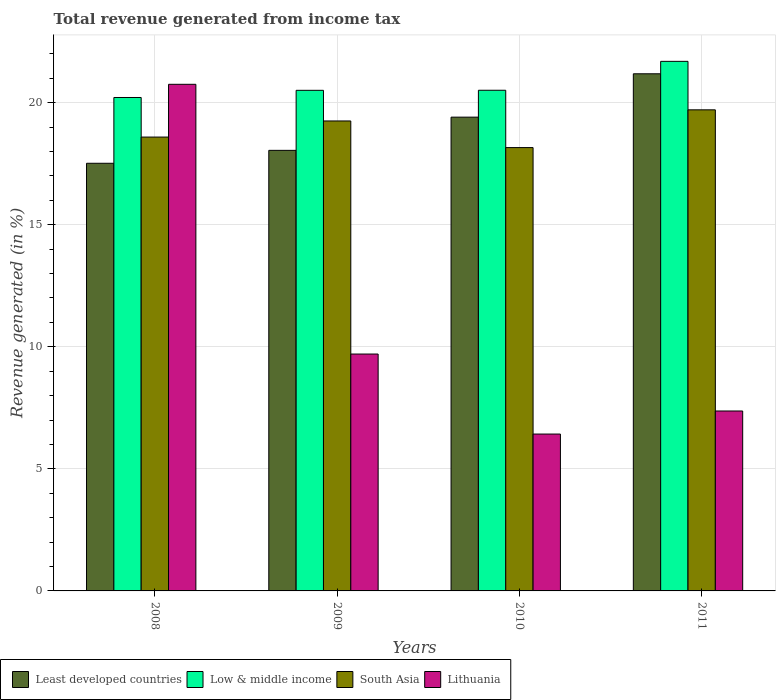How many different coloured bars are there?
Give a very brief answer. 4. How many groups of bars are there?
Make the answer very short. 4. What is the label of the 1st group of bars from the left?
Offer a very short reply. 2008. In how many cases, is the number of bars for a given year not equal to the number of legend labels?
Make the answer very short. 0. What is the total revenue generated in South Asia in 2010?
Your answer should be compact. 18.16. Across all years, what is the maximum total revenue generated in South Asia?
Give a very brief answer. 19.7. Across all years, what is the minimum total revenue generated in Lithuania?
Make the answer very short. 6.42. What is the total total revenue generated in South Asia in the graph?
Provide a succinct answer. 75.7. What is the difference between the total revenue generated in Least developed countries in 2008 and that in 2010?
Give a very brief answer. -1.89. What is the difference between the total revenue generated in Least developed countries in 2011 and the total revenue generated in Low & middle income in 2010?
Ensure brevity in your answer.  0.67. What is the average total revenue generated in South Asia per year?
Offer a very short reply. 18.92. In the year 2011, what is the difference between the total revenue generated in Least developed countries and total revenue generated in South Asia?
Make the answer very short. 1.48. In how many years, is the total revenue generated in Low & middle income greater than 20 %?
Your answer should be compact. 4. What is the ratio of the total revenue generated in Least developed countries in 2009 to that in 2011?
Keep it short and to the point. 0.85. Is the total revenue generated in Low & middle income in 2008 less than that in 2009?
Give a very brief answer. Yes. Is the difference between the total revenue generated in Least developed countries in 2008 and 2010 greater than the difference between the total revenue generated in South Asia in 2008 and 2010?
Give a very brief answer. No. What is the difference between the highest and the second highest total revenue generated in South Asia?
Your response must be concise. 0.46. What is the difference between the highest and the lowest total revenue generated in Least developed countries?
Your response must be concise. 3.67. Is the sum of the total revenue generated in Lithuania in 2008 and 2010 greater than the maximum total revenue generated in South Asia across all years?
Your answer should be very brief. Yes. Is it the case that in every year, the sum of the total revenue generated in Low & middle income and total revenue generated in South Asia is greater than the sum of total revenue generated in Lithuania and total revenue generated in Least developed countries?
Offer a terse response. Yes. What does the 1st bar from the left in 2010 represents?
Your answer should be compact. Least developed countries. What does the 1st bar from the right in 2009 represents?
Make the answer very short. Lithuania. Is it the case that in every year, the sum of the total revenue generated in South Asia and total revenue generated in Least developed countries is greater than the total revenue generated in Lithuania?
Provide a short and direct response. Yes. How many legend labels are there?
Your answer should be compact. 4. What is the title of the graph?
Your answer should be very brief. Total revenue generated from income tax. Does "Comoros" appear as one of the legend labels in the graph?
Your answer should be compact. No. What is the label or title of the Y-axis?
Offer a very short reply. Revenue generated (in %). What is the Revenue generated (in %) of Least developed countries in 2008?
Offer a very short reply. 17.52. What is the Revenue generated (in %) in Low & middle income in 2008?
Provide a short and direct response. 20.21. What is the Revenue generated (in %) in South Asia in 2008?
Your answer should be very brief. 18.59. What is the Revenue generated (in %) in Lithuania in 2008?
Ensure brevity in your answer.  20.75. What is the Revenue generated (in %) in Least developed countries in 2009?
Offer a very short reply. 18.04. What is the Revenue generated (in %) of Low & middle income in 2009?
Your response must be concise. 20.5. What is the Revenue generated (in %) in South Asia in 2009?
Provide a succinct answer. 19.25. What is the Revenue generated (in %) in Lithuania in 2009?
Offer a very short reply. 9.7. What is the Revenue generated (in %) in Least developed countries in 2010?
Keep it short and to the point. 19.4. What is the Revenue generated (in %) of Low & middle income in 2010?
Give a very brief answer. 20.51. What is the Revenue generated (in %) in South Asia in 2010?
Your answer should be very brief. 18.16. What is the Revenue generated (in %) of Lithuania in 2010?
Make the answer very short. 6.42. What is the Revenue generated (in %) in Least developed countries in 2011?
Offer a very short reply. 21.18. What is the Revenue generated (in %) in Low & middle income in 2011?
Provide a succinct answer. 21.69. What is the Revenue generated (in %) of South Asia in 2011?
Provide a short and direct response. 19.7. What is the Revenue generated (in %) in Lithuania in 2011?
Provide a succinct answer. 7.37. Across all years, what is the maximum Revenue generated (in %) in Least developed countries?
Your answer should be very brief. 21.18. Across all years, what is the maximum Revenue generated (in %) in Low & middle income?
Your answer should be compact. 21.69. Across all years, what is the maximum Revenue generated (in %) in South Asia?
Give a very brief answer. 19.7. Across all years, what is the maximum Revenue generated (in %) of Lithuania?
Provide a short and direct response. 20.75. Across all years, what is the minimum Revenue generated (in %) in Least developed countries?
Make the answer very short. 17.52. Across all years, what is the minimum Revenue generated (in %) of Low & middle income?
Give a very brief answer. 20.21. Across all years, what is the minimum Revenue generated (in %) in South Asia?
Provide a short and direct response. 18.16. Across all years, what is the minimum Revenue generated (in %) of Lithuania?
Provide a short and direct response. 6.42. What is the total Revenue generated (in %) of Least developed countries in the graph?
Provide a short and direct response. 76.15. What is the total Revenue generated (in %) of Low & middle income in the graph?
Ensure brevity in your answer.  82.91. What is the total Revenue generated (in %) of South Asia in the graph?
Your answer should be compact. 75.7. What is the total Revenue generated (in %) of Lithuania in the graph?
Provide a short and direct response. 44.25. What is the difference between the Revenue generated (in %) in Least developed countries in 2008 and that in 2009?
Give a very brief answer. -0.53. What is the difference between the Revenue generated (in %) of Low & middle income in 2008 and that in 2009?
Provide a short and direct response. -0.29. What is the difference between the Revenue generated (in %) of South Asia in 2008 and that in 2009?
Ensure brevity in your answer.  -0.66. What is the difference between the Revenue generated (in %) in Lithuania in 2008 and that in 2009?
Offer a very short reply. 11.05. What is the difference between the Revenue generated (in %) in Least developed countries in 2008 and that in 2010?
Make the answer very short. -1.89. What is the difference between the Revenue generated (in %) in Low & middle income in 2008 and that in 2010?
Your response must be concise. -0.3. What is the difference between the Revenue generated (in %) in South Asia in 2008 and that in 2010?
Your response must be concise. 0.43. What is the difference between the Revenue generated (in %) of Lithuania in 2008 and that in 2010?
Your answer should be very brief. 14.32. What is the difference between the Revenue generated (in %) in Least developed countries in 2008 and that in 2011?
Your response must be concise. -3.67. What is the difference between the Revenue generated (in %) of Low & middle income in 2008 and that in 2011?
Your answer should be compact. -1.48. What is the difference between the Revenue generated (in %) of South Asia in 2008 and that in 2011?
Your answer should be very brief. -1.12. What is the difference between the Revenue generated (in %) in Lithuania in 2008 and that in 2011?
Give a very brief answer. 13.38. What is the difference between the Revenue generated (in %) in Least developed countries in 2009 and that in 2010?
Ensure brevity in your answer.  -1.36. What is the difference between the Revenue generated (in %) of Low & middle income in 2009 and that in 2010?
Give a very brief answer. -0. What is the difference between the Revenue generated (in %) in South Asia in 2009 and that in 2010?
Provide a succinct answer. 1.09. What is the difference between the Revenue generated (in %) of Lithuania in 2009 and that in 2010?
Make the answer very short. 3.28. What is the difference between the Revenue generated (in %) of Least developed countries in 2009 and that in 2011?
Ensure brevity in your answer.  -3.14. What is the difference between the Revenue generated (in %) in Low & middle income in 2009 and that in 2011?
Ensure brevity in your answer.  -1.19. What is the difference between the Revenue generated (in %) of South Asia in 2009 and that in 2011?
Make the answer very short. -0.46. What is the difference between the Revenue generated (in %) of Lithuania in 2009 and that in 2011?
Provide a succinct answer. 2.33. What is the difference between the Revenue generated (in %) of Least developed countries in 2010 and that in 2011?
Your answer should be compact. -1.78. What is the difference between the Revenue generated (in %) in Low & middle income in 2010 and that in 2011?
Make the answer very short. -1.18. What is the difference between the Revenue generated (in %) in South Asia in 2010 and that in 2011?
Make the answer very short. -1.55. What is the difference between the Revenue generated (in %) in Lithuania in 2010 and that in 2011?
Provide a short and direct response. -0.94. What is the difference between the Revenue generated (in %) in Least developed countries in 2008 and the Revenue generated (in %) in Low & middle income in 2009?
Give a very brief answer. -2.99. What is the difference between the Revenue generated (in %) in Least developed countries in 2008 and the Revenue generated (in %) in South Asia in 2009?
Your answer should be compact. -1.73. What is the difference between the Revenue generated (in %) in Least developed countries in 2008 and the Revenue generated (in %) in Lithuania in 2009?
Your answer should be compact. 7.81. What is the difference between the Revenue generated (in %) of Low & middle income in 2008 and the Revenue generated (in %) of South Asia in 2009?
Provide a succinct answer. 0.96. What is the difference between the Revenue generated (in %) in Low & middle income in 2008 and the Revenue generated (in %) in Lithuania in 2009?
Ensure brevity in your answer.  10.51. What is the difference between the Revenue generated (in %) of South Asia in 2008 and the Revenue generated (in %) of Lithuania in 2009?
Your answer should be compact. 8.89. What is the difference between the Revenue generated (in %) in Least developed countries in 2008 and the Revenue generated (in %) in Low & middle income in 2010?
Your answer should be compact. -2.99. What is the difference between the Revenue generated (in %) of Least developed countries in 2008 and the Revenue generated (in %) of South Asia in 2010?
Your answer should be compact. -0.64. What is the difference between the Revenue generated (in %) in Least developed countries in 2008 and the Revenue generated (in %) in Lithuania in 2010?
Give a very brief answer. 11.09. What is the difference between the Revenue generated (in %) in Low & middle income in 2008 and the Revenue generated (in %) in South Asia in 2010?
Offer a very short reply. 2.05. What is the difference between the Revenue generated (in %) in Low & middle income in 2008 and the Revenue generated (in %) in Lithuania in 2010?
Make the answer very short. 13.78. What is the difference between the Revenue generated (in %) in South Asia in 2008 and the Revenue generated (in %) in Lithuania in 2010?
Keep it short and to the point. 12.16. What is the difference between the Revenue generated (in %) of Least developed countries in 2008 and the Revenue generated (in %) of Low & middle income in 2011?
Provide a short and direct response. -4.17. What is the difference between the Revenue generated (in %) of Least developed countries in 2008 and the Revenue generated (in %) of South Asia in 2011?
Your response must be concise. -2.19. What is the difference between the Revenue generated (in %) in Least developed countries in 2008 and the Revenue generated (in %) in Lithuania in 2011?
Provide a succinct answer. 10.15. What is the difference between the Revenue generated (in %) of Low & middle income in 2008 and the Revenue generated (in %) of South Asia in 2011?
Make the answer very short. 0.51. What is the difference between the Revenue generated (in %) in Low & middle income in 2008 and the Revenue generated (in %) in Lithuania in 2011?
Provide a succinct answer. 12.84. What is the difference between the Revenue generated (in %) of South Asia in 2008 and the Revenue generated (in %) of Lithuania in 2011?
Ensure brevity in your answer.  11.22. What is the difference between the Revenue generated (in %) in Least developed countries in 2009 and the Revenue generated (in %) in Low & middle income in 2010?
Your response must be concise. -2.46. What is the difference between the Revenue generated (in %) of Least developed countries in 2009 and the Revenue generated (in %) of South Asia in 2010?
Make the answer very short. -0.11. What is the difference between the Revenue generated (in %) in Least developed countries in 2009 and the Revenue generated (in %) in Lithuania in 2010?
Provide a succinct answer. 11.62. What is the difference between the Revenue generated (in %) in Low & middle income in 2009 and the Revenue generated (in %) in South Asia in 2010?
Offer a very short reply. 2.35. What is the difference between the Revenue generated (in %) of Low & middle income in 2009 and the Revenue generated (in %) of Lithuania in 2010?
Keep it short and to the point. 14.08. What is the difference between the Revenue generated (in %) of South Asia in 2009 and the Revenue generated (in %) of Lithuania in 2010?
Your response must be concise. 12.82. What is the difference between the Revenue generated (in %) in Least developed countries in 2009 and the Revenue generated (in %) in Low & middle income in 2011?
Offer a terse response. -3.65. What is the difference between the Revenue generated (in %) in Least developed countries in 2009 and the Revenue generated (in %) in South Asia in 2011?
Provide a short and direct response. -1.66. What is the difference between the Revenue generated (in %) in Least developed countries in 2009 and the Revenue generated (in %) in Lithuania in 2011?
Your answer should be very brief. 10.68. What is the difference between the Revenue generated (in %) in Low & middle income in 2009 and the Revenue generated (in %) in South Asia in 2011?
Your response must be concise. 0.8. What is the difference between the Revenue generated (in %) of Low & middle income in 2009 and the Revenue generated (in %) of Lithuania in 2011?
Your response must be concise. 13.13. What is the difference between the Revenue generated (in %) in South Asia in 2009 and the Revenue generated (in %) in Lithuania in 2011?
Ensure brevity in your answer.  11.88. What is the difference between the Revenue generated (in %) in Least developed countries in 2010 and the Revenue generated (in %) in Low & middle income in 2011?
Offer a terse response. -2.29. What is the difference between the Revenue generated (in %) in Least developed countries in 2010 and the Revenue generated (in %) in South Asia in 2011?
Ensure brevity in your answer.  -0.3. What is the difference between the Revenue generated (in %) in Least developed countries in 2010 and the Revenue generated (in %) in Lithuania in 2011?
Your answer should be compact. 12.04. What is the difference between the Revenue generated (in %) of Low & middle income in 2010 and the Revenue generated (in %) of South Asia in 2011?
Keep it short and to the point. 0.8. What is the difference between the Revenue generated (in %) of Low & middle income in 2010 and the Revenue generated (in %) of Lithuania in 2011?
Keep it short and to the point. 13.14. What is the difference between the Revenue generated (in %) in South Asia in 2010 and the Revenue generated (in %) in Lithuania in 2011?
Give a very brief answer. 10.79. What is the average Revenue generated (in %) of Least developed countries per year?
Offer a terse response. 19.04. What is the average Revenue generated (in %) in Low & middle income per year?
Your answer should be very brief. 20.73. What is the average Revenue generated (in %) of South Asia per year?
Your answer should be compact. 18.92. What is the average Revenue generated (in %) in Lithuania per year?
Offer a very short reply. 11.06. In the year 2008, what is the difference between the Revenue generated (in %) of Least developed countries and Revenue generated (in %) of Low & middle income?
Ensure brevity in your answer.  -2.69. In the year 2008, what is the difference between the Revenue generated (in %) of Least developed countries and Revenue generated (in %) of South Asia?
Provide a succinct answer. -1.07. In the year 2008, what is the difference between the Revenue generated (in %) in Least developed countries and Revenue generated (in %) in Lithuania?
Your answer should be very brief. -3.23. In the year 2008, what is the difference between the Revenue generated (in %) of Low & middle income and Revenue generated (in %) of South Asia?
Keep it short and to the point. 1.62. In the year 2008, what is the difference between the Revenue generated (in %) of Low & middle income and Revenue generated (in %) of Lithuania?
Keep it short and to the point. -0.54. In the year 2008, what is the difference between the Revenue generated (in %) of South Asia and Revenue generated (in %) of Lithuania?
Make the answer very short. -2.16. In the year 2009, what is the difference between the Revenue generated (in %) in Least developed countries and Revenue generated (in %) in Low & middle income?
Make the answer very short. -2.46. In the year 2009, what is the difference between the Revenue generated (in %) in Least developed countries and Revenue generated (in %) in South Asia?
Your answer should be very brief. -1.2. In the year 2009, what is the difference between the Revenue generated (in %) of Least developed countries and Revenue generated (in %) of Lithuania?
Your answer should be very brief. 8.34. In the year 2009, what is the difference between the Revenue generated (in %) of Low & middle income and Revenue generated (in %) of South Asia?
Your answer should be compact. 1.26. In the year 2009, what is the difference between the Revenue generated (in %) of Low & middle income and Revenue generated (in %) of Lithuania?
Give a very brief answer. 10.8. In the year 2009, what is the difference between the Revenue generated (in %) in South Asia and Revenue generated (in %) in Lithuania?
Offer a very short reply. 9.55. In the year 2010, what is the difference between the Revenue generated (in %) of Least developed countries and Revenue generated (in %) of Low & middle income?
Provide a succinct answer. -1.1. In the year 2010, what is the difference between the Revenue generated (in %) in Least developed countries and Revenue generated (in %) in South Asia?
Make the answer very short. 1.25. In the year 2010, what is the difference between the Revenue generated (in %) in Least developed countries and Revenue generated (in %) in Lithuania?
Your answer should be very brief. 12.98. In the year 2010, what is the difference between the Revenue generated (in %) in Low & middle income and Revenue generated (in %) in South Asia?
Offer a terse response. 2.35. In the year 2010, what is the difference between the Revenue generated (in %) in Low & middle income and Revenue generated (in %) in Lithuania?
Your response must be concise. 14.08. In the year 2010, what is the difference between the Revenue generated (in %) in South Asia and Revenue generated (in %) in Lithuania?
Your answer should be very brief. 11.73. In the year 2011, what is the difference between the Revenue generated (in %) in Least developed countries and Revenue generated (in %) in Low & middle income?
Offer a terse response. -0.51. In the year 2011, what is the difference between the Revenue generated (in %) in Least developed countries and Revenue generated (in %) in South Asia?
Your answer should be very brief. 1.48. In the year 2011, what is the difference between the Revenue generated (in %) in Least developed countries and Revenue generated (in %) in Lithuania?
Offer a terse response. 13.81. In the year 2011, what is the difference between the Revenue generated (in %) of Low & middle income and Revenue generated (in %) of South Asia?
Offer a terse response. 1.99. In the year 2011, what is the difference between the Revenue generated (in %) in Low & middle income and Revenue generated (in %) in Lithuania?
Keep it short and to the point. 14.32. In the year 2011, what is the difference between the Revenue generated (in %) in South Asia and Revenue generated (in %) in Lithuania?
Your answer should be very brief. 12.33. What is the ratio of the Revenue generated (in %) of Least developed countries in 2008 to that in 2009?
Your answer should be very brief. 0.97. What is the ratio of the Revenue generated (in %) of Low & middle income in 2008 to that in 2009?
Keep it short and to the point. 0.99. What is the ratio of the Revenue generated (in %) of South Asia in 2008 to that in 2009?
Provide a short and direct response. 0.97. What is the ratio of the Revenue generated (in %) of Lithuania in 2008 to that in 2009?
Your response must be concise. 2.14. What is the ratio of the Revenue generated (in %) of Least developed countries in 2008 to that in 2010?
Your response must be concise. 0.9. What is the ratio of the Revenue generated (in %) of Low & middle income in 2008 to that in 2010?
Give a very brief answer. 0.99. What is the ratio of the Revenue generated (in %) in South Asia in 2008 to that in 2010?
Keep it short and to the point. 1.02. What is the ratio of the Revenue generated (in %) of Lithuania in 2008 to that in 2010?
Ensure brevity in your answer.  3.23. What is the ratio of the Revenue generated (in %) of Least developed countries in 2008 to that in 2011?
Provide a succinct answer. 0.83. What is the ratio of the Revenue generated (in %) of Low & middle income in 2008 to that in 2011?
Keep it short and to the point. 0.93. What is the ratio of the Revenue generated (in %) of South Asia in 2008 to that in 2011?
Keep it short and to the point. 0.94. What is the ratio of the Revenue generated (in %) in Lithuania in 2008 to that in 2011?
Provide a short and direct response. 2.82. What is the ratio of the Revenue generated (in %) of Least developed countries in 2009 to that in 2010?
Provide a succinct answer. 0.93. What is the ratio of the Revenue generated (in %) in Low & middle income in 2009 to that in 2010?
Your response must be concise. 1. What is the ratio of the Revenue generated (in %) in South Asia in 2009 to that in 2010?
Offer a very short reply. 1.06. What is the ratio of the Revenue generated (in %) in Lithuania in 2009 to that in 2010?
Give a very brief answer. 1.51. What is the ratio of the Revenue generated (in %) in Least developed countries in 2009 to that in 2011?
Make the answer very short. 0.85. What is the ratio of the Revenue generated (in %) in Low & middle income in 2009 to that in 2011?
Your response must be concise. 0.95. What is the ratio of the Revenue generated (in %) of South Asia in 2009 to that in 2011?
Provide a short and direct response. 0.98. What is the ratio of the Revenue generated (in %) in Lithuania in 2009 to that in 2011?
Ensure brevity in your answer.  1.32. What is the ratio of the Revenue generated (in %) in Least developed countries in 2010 to that in 2011?
Give a very brief answer. 0.92. What is the ratio of the Revenue generated (in %) in Low & middle income in 2010 to that in 2011?
Keep it short and to the point. 0.95. What is the ratio of the Revenue generated (in %) of South Asia in 2010 to that in 2011?
Make the answer very short. 0.92. What is the ratio of the Revenue generated (in %) in Lithuania in 2010 to that in 2011?
Give a very brief answer. 0.87. What is the difference between the highest and the second highest Revenue generated (in %) in Least developed countries?
Your answer should be compact. 1.78. What is the difference between the highest and the second highest Revenue generated (in %) in Low & middle income?
Provide a succinct answer. 1.18. What is the difference between the highest and the second highest Revenue generated (in %) in South Asia?
Give a very brief answer. 0.46. What is the difference between the highest and the second highest Revenue generated (in %) of Lithuania?
Keep it short and to the point. 11.05. What is the difference between the highest and the lowest Revenue generated (in %) of Least developed countries?
Your answer should be very brief. 3.67. What is the difference between the highest and the lowest Revenue generated (in %) in Low & middle income?
Keep it short and to the point. 1.48. What is the difference between the highest and the lowest Revenue generated (in %) in South Asia?
Keep it short and to the point. 1.55. What is the difference between the highest and the lowest Revenue generated (in %) in Lithuania?
Make the answer very short. 14.32. 